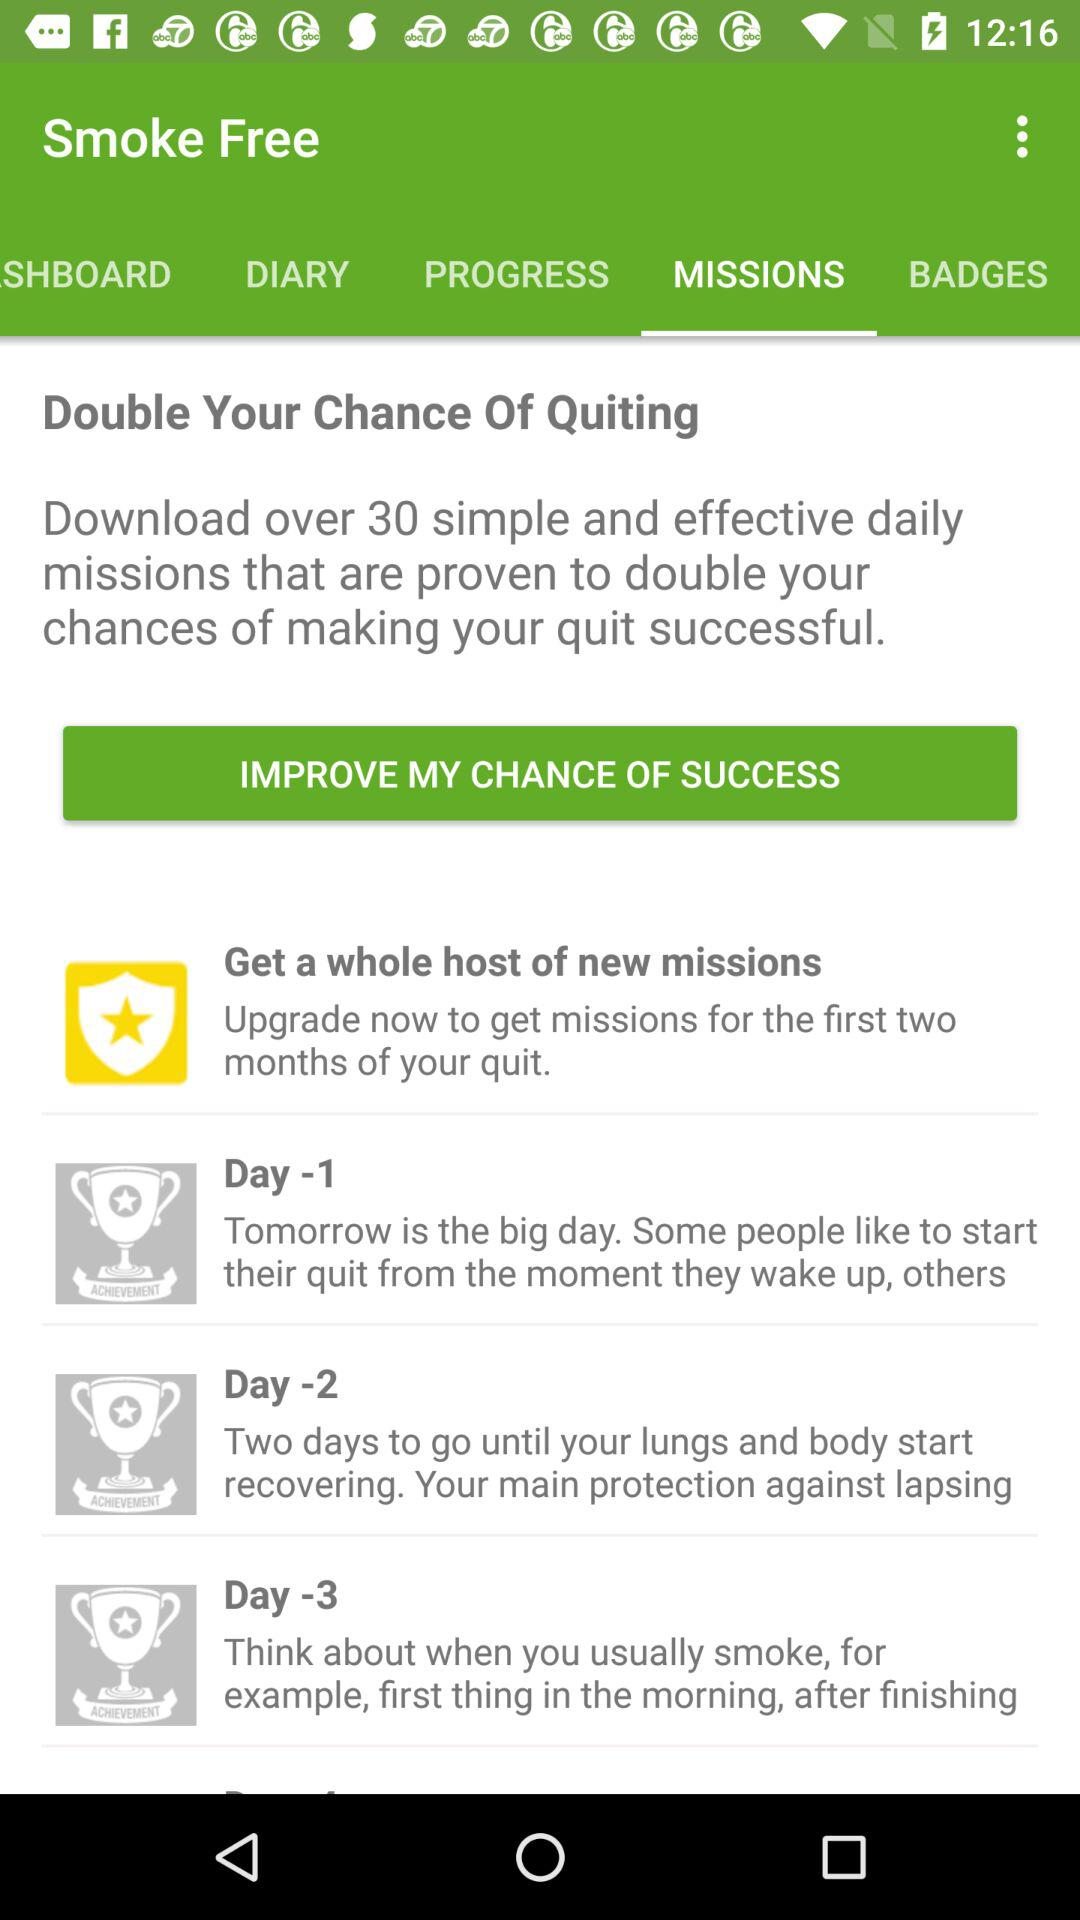What's the app's name? The app's name is "Smoke Free". 